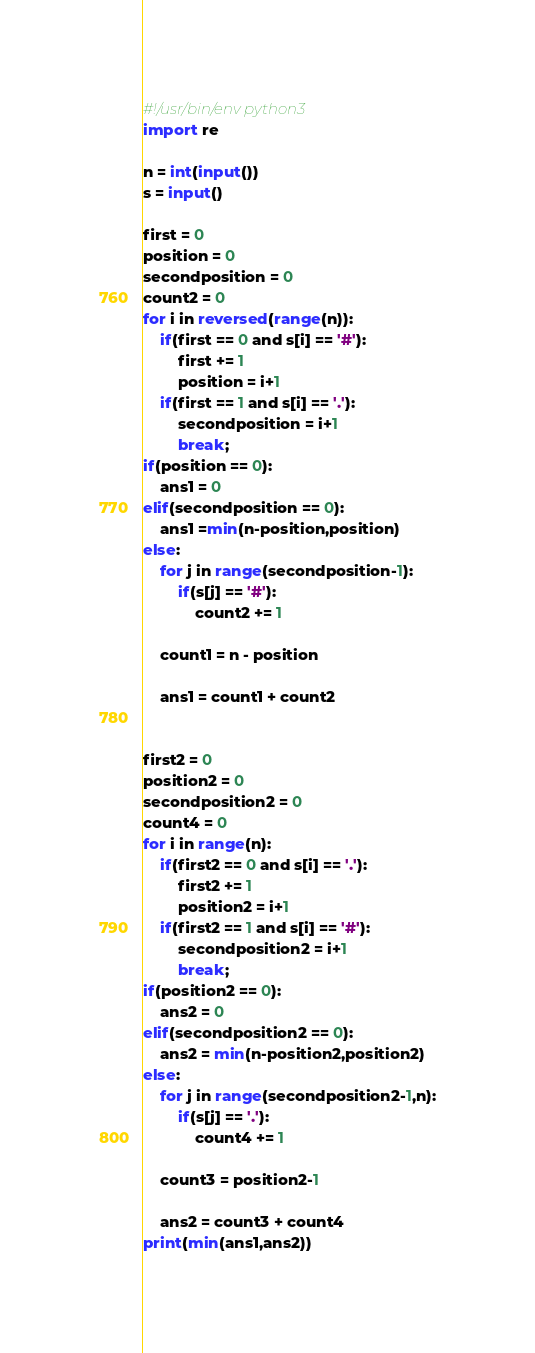Convert code to text. <code><loc_0><loc_0><loc_500><loc_500><_Python_>#!/usr/bin/env python3
import re

n = int(input())
s = input()

first = 0
position = 0
secondposition = 0
count2 = 0
for i in reversed(range(n)):
    if(first == 0 and s[i] == '#'):
        first += 1
        position = i+1
    if(first == 1 and s[i] == '.'):
        secondposition = i+1
        break;
if(position == 0):
    ans1 = 0
elif(secondposition == 0):
    ans1 =min(n-position,position)
else:
    for j in range(secondposition-1):
        if(s[j] == '#'):
            count2 += 1

    count1 = n - position

    ans1 = count1 + count2


first2 = 0
position2 = 0
secondposition2 = 0
count4 = 0
for i in range(n):
    if(first2 == 0 and s[i] == '.'):
        first2 += 1
        position2 = i+1
    if(first2 == 1 and s[i] == '#'):
        secondposition2 = i+1
        break;
if(position2 == 0):
    ans2 = 0
elif(secondposition2 == 0):
    ans2 = min(n-position2,position2)
else:
    for j in range(secondposition2-1,n):
        if(s[j] == '.'):
            count4 += 1

    count3 = position2-1

    ans2 = count3 + count4
print(min(ans1,ans2))</code> 